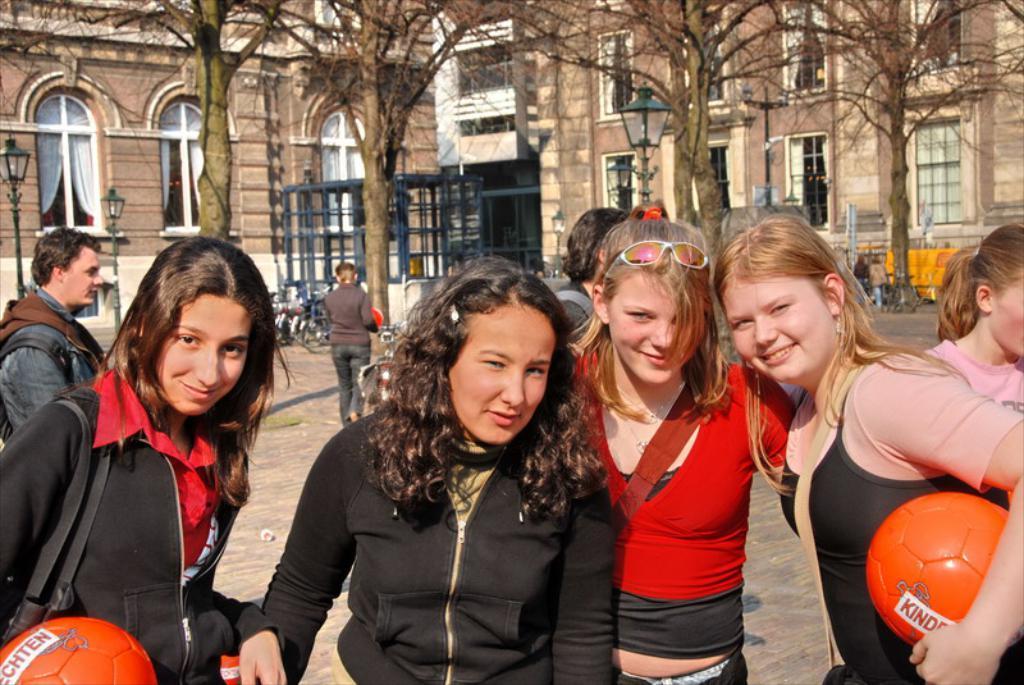Please provide a concise description of this image. This image is clicked outside. There are on the top and there is a building on the top. To that building there are Windows and curtains there are people standing in the middle. The one who is on the right and the one who is on the left are holding balls there are vehicles in the middle. There are lights on the right left side. 